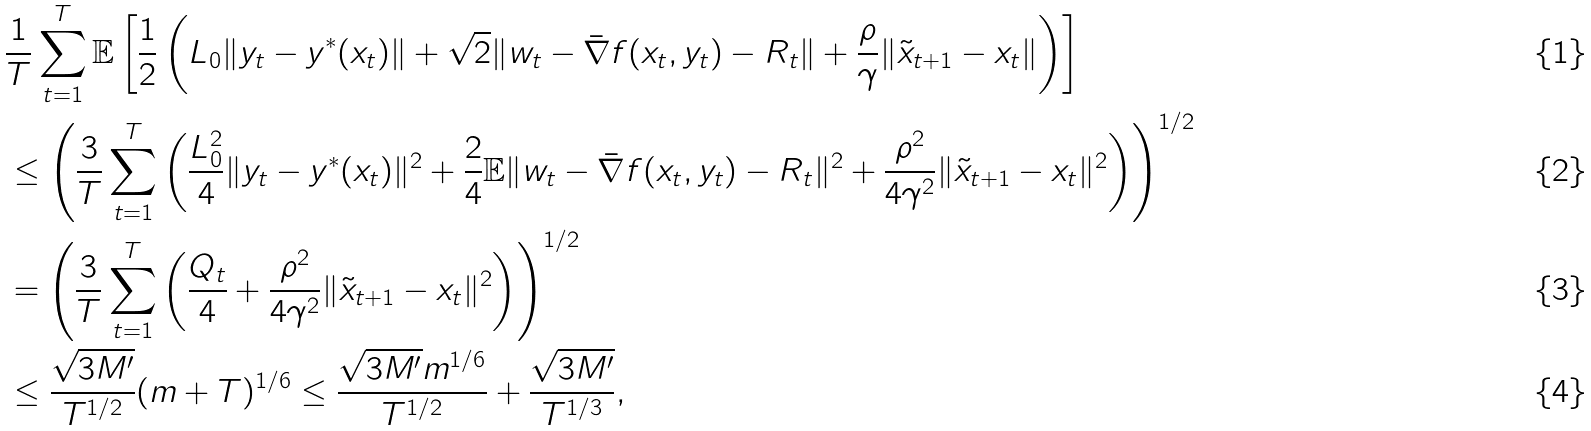Convert formula to latex. <formula><loc_0><loc_0><loc_500><loc_500>& \frac { 1 } { T } \sum _ { t = 1 } ^ { T } \mathbb { E } \left [ \frac { 1 } { 2 } \left ( L _ { 0 } \| y _ { t } - y ^ { * } ( x _ { t } ) \| + \sqrt { 2 } \| w _ { t } - \bar { \nabla } f ( x _ { t } , y _ { t } ) - R _ { t } \| + \frac { \rho } { \gamma } \| \tilde { x } _ { t + 1 } - x _ { t } \| \right ) \right ] \\ & \leq \left ( \frac { 3 } { T } \sum _ { t = 1 } ^ { T } \left ( \frac { L ^ { 2 } _ { 0 } } { 4 } \| y _ { t } - y ^ { * } ( x _ { t } ) \| ^ { 2 } + \frac { 2 } { 4 } \mathbb { E } \| w _ { t } - \bar { \nabla } f ( x _ { t } , y _ { t } ) - R _ { t } \| ^ { 2 } + \frac { \rho ^ { 2 } } { 4 \gamma ^ { 2 } } \| \tilde { x } _ { t + 1 } - x _ { t } \| ^ { 2 } \right ) \right ) ^ { 1 / 2 } \\ & = \left ( \frac { 3 } { T } \sum _ { t = 1 } ^ { T } \left ( \frac { Q _ { t } } { 4 } + \frac { \rho ^ { 2 } } { 4 \gamma ^ { 2 } } \| \tilde { x } _ { t + 1 } - x _ { t } \| ^ { 2 } \right ) \right ) ^ { 1 / 2 } \\ & \leq \frac { \sqrt { 3 M ^ { \prime } } } { T ^ { 1 / 2 } } ( m + T ) ^ { 1 / 6 } \leq \frac { \sqrt { 3 M ^ { \prime } } m ^ { 1 / 6 } } { T ^ { 1 / 2 } } + \frac { \sqrt { 3 M ^ { \prime } } } { T ^ { 1 / 3 } } ,</formula> 